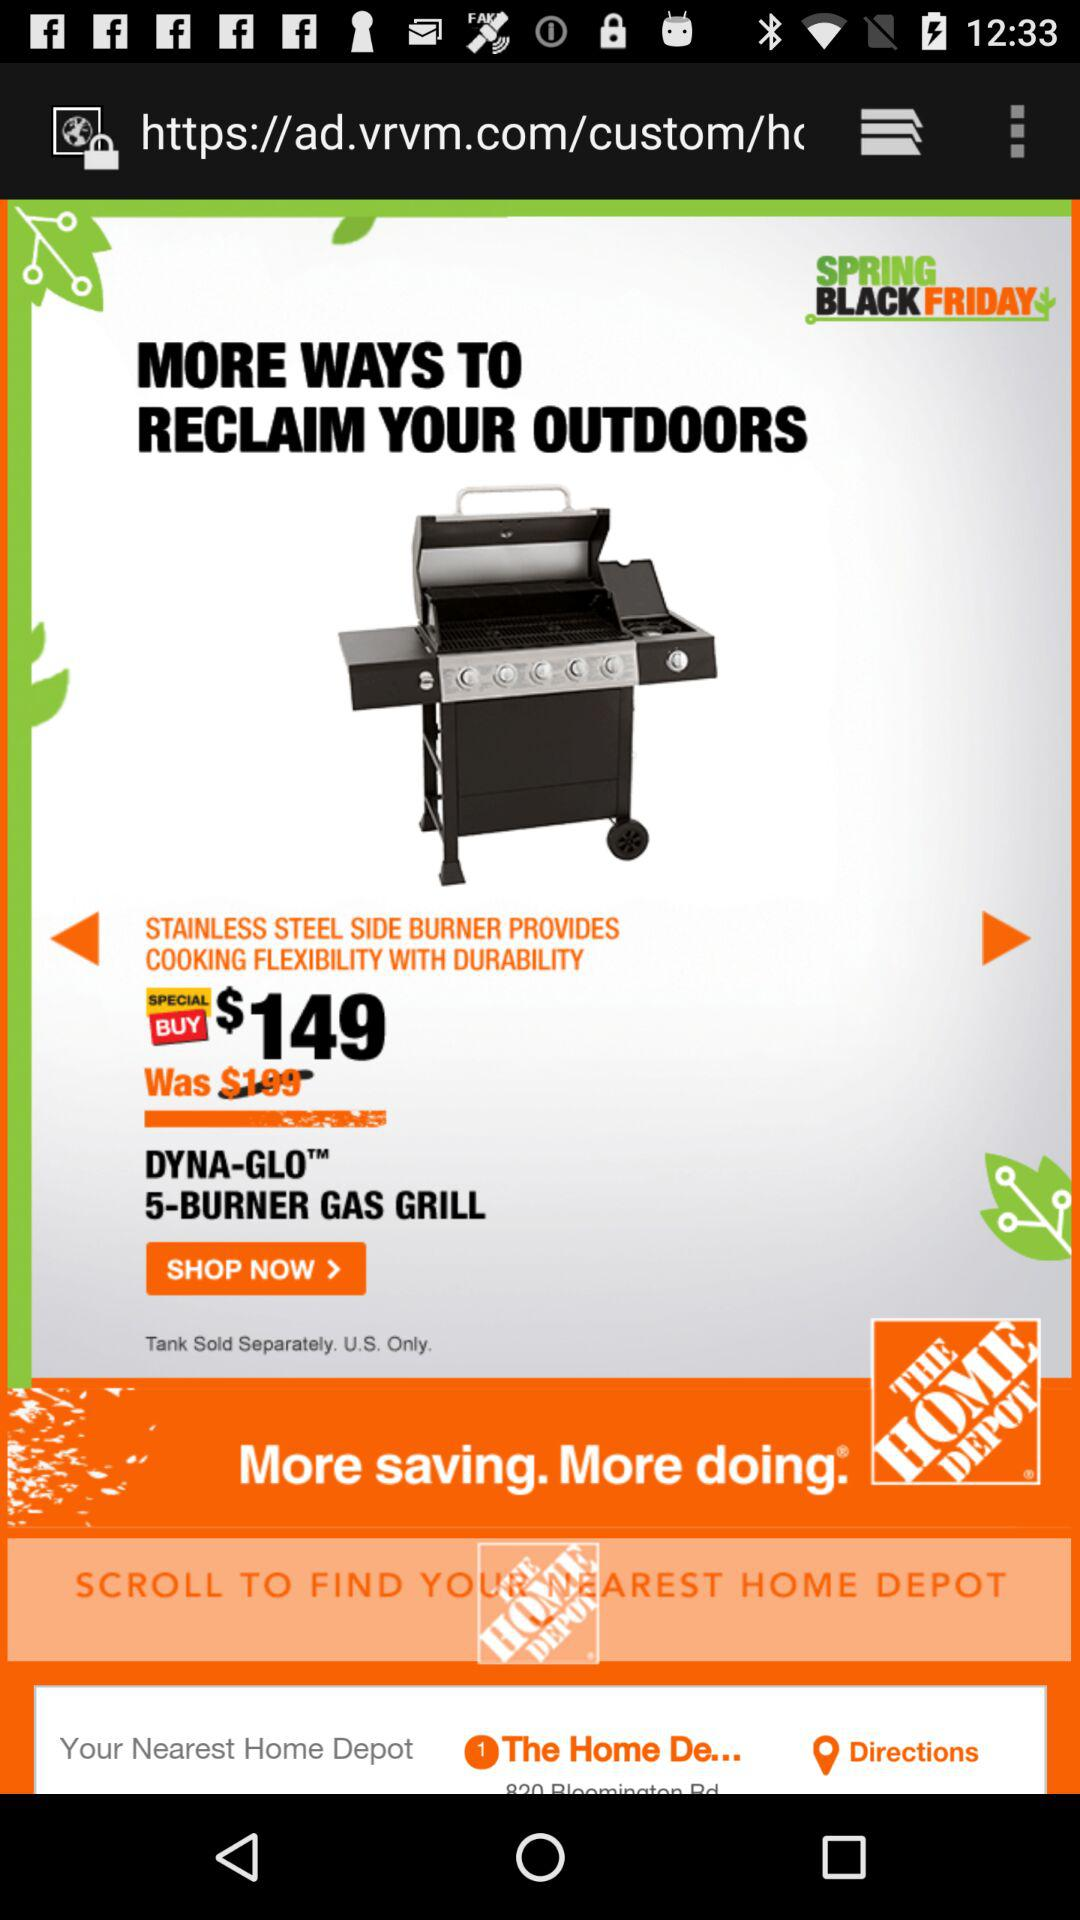Where is the nearest Home Depot located?
When the provided information is insufficient, respond with <no answer>. <no answer> 